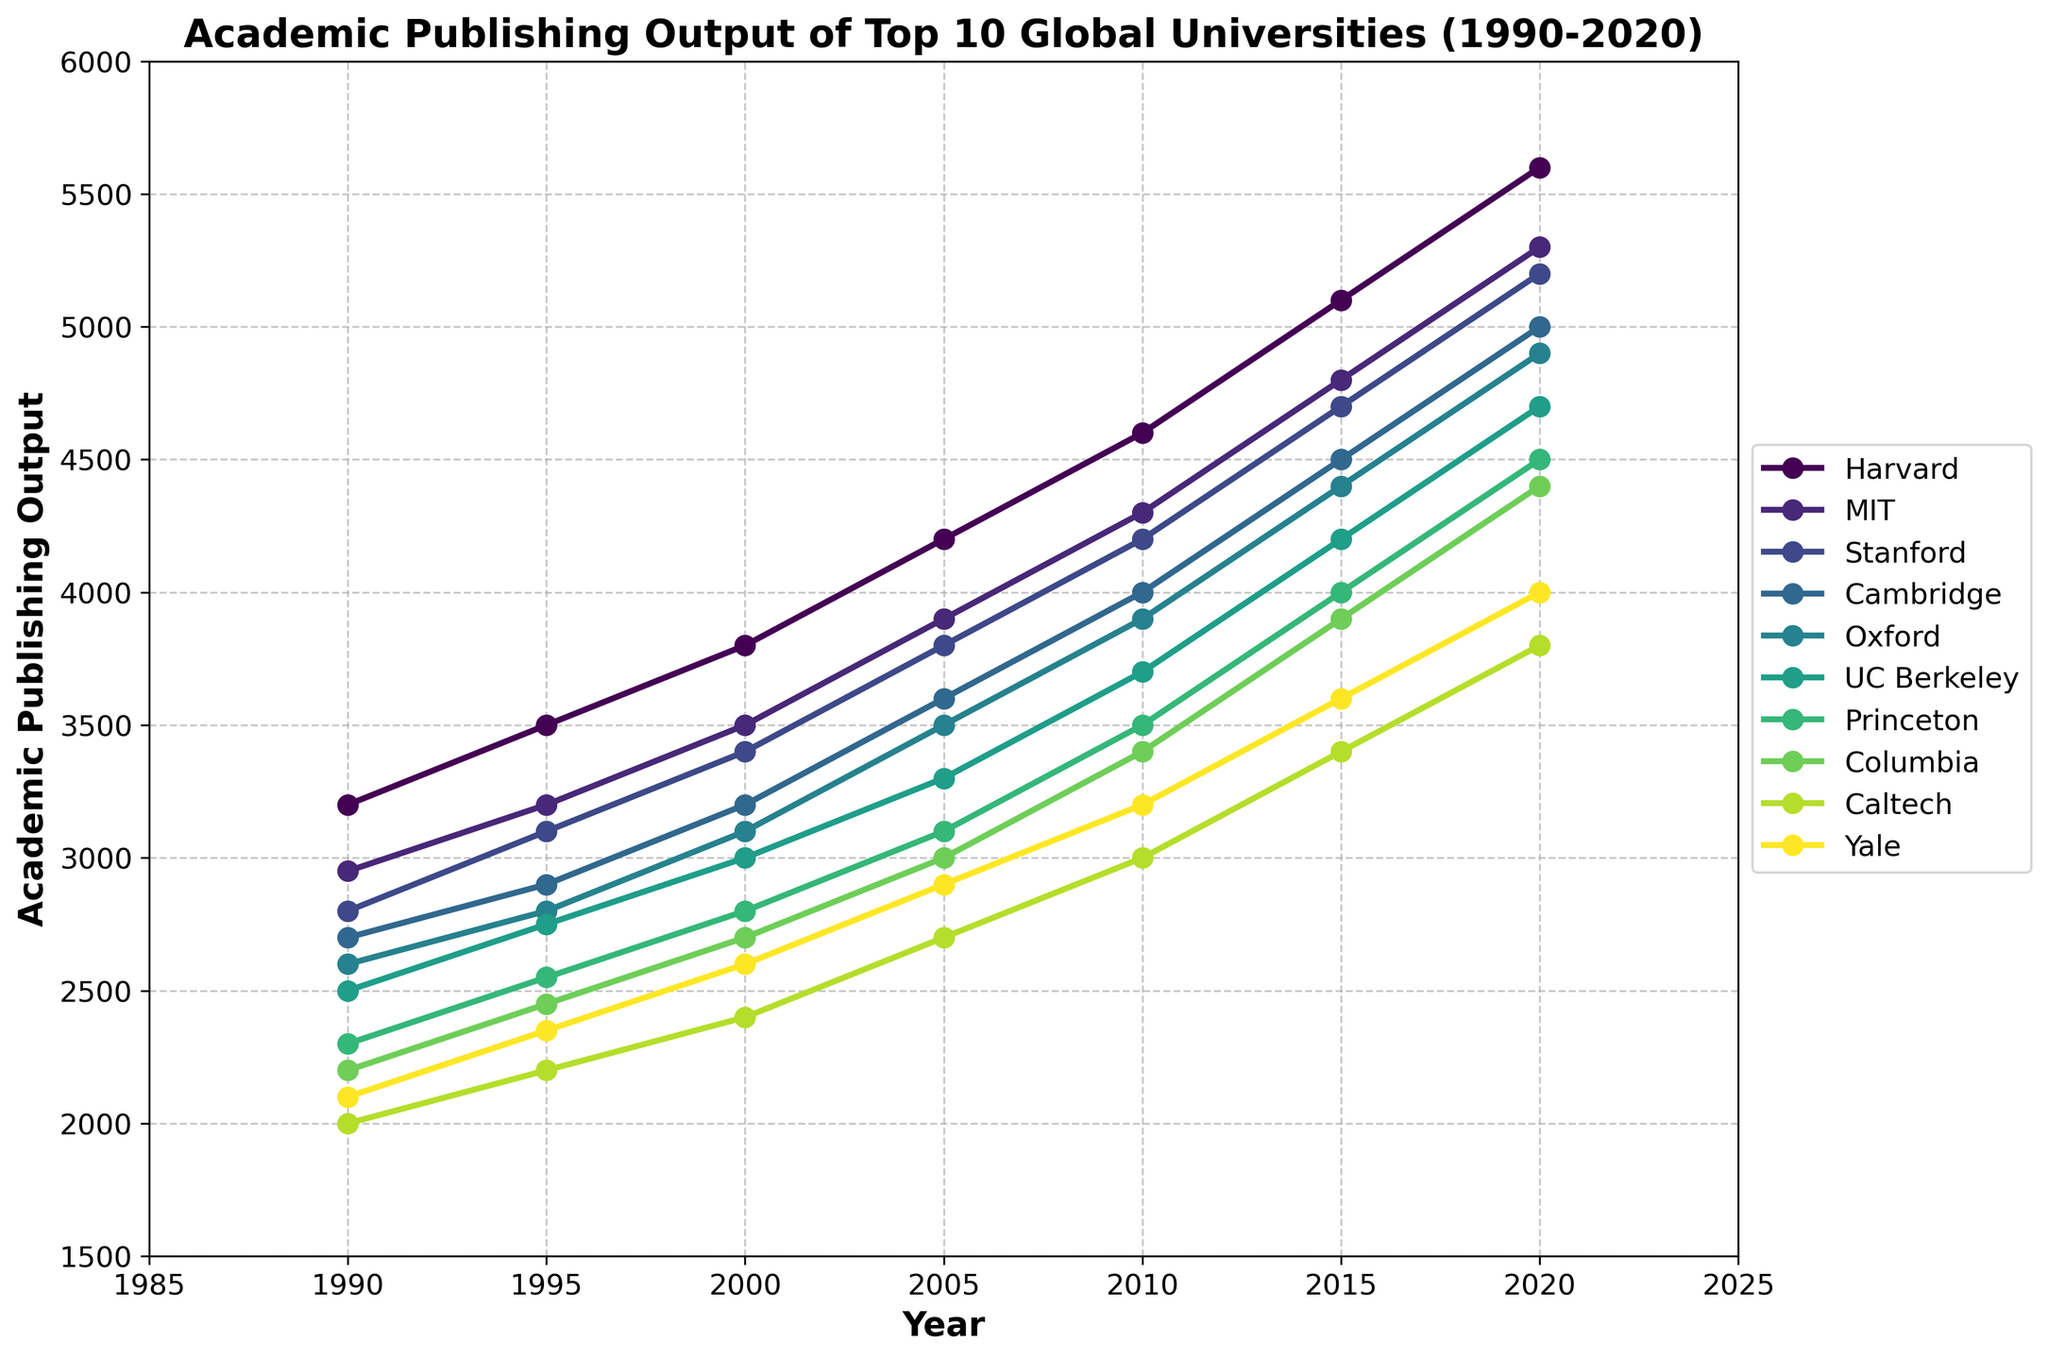What is the publishing output of MIT in 2010? From the figure, look at the point corresponding to MIT for the year 2010. According to the plot, MIT's academic publishing output for that year is 4300.
Answer: 4300 Which university had the highest publishing output in 2020? Look for the highest point on the plot for the year 2020. Harvard has the highest publishing output in 2020 with 5600.
Answer: Harvard How does Harvard's publishing output in 2020 compare to its output in 1990? Identify Harvard's publishing output in both 2020 and 1990. Harvard's output in 2020 is 5600, and in 1990 it is 3200. The difference is 5600 - 3200 = 2400, so it increased by 2400.
Answer: Harvard's publishing output increased by 2400 Between 1990 and 2020, which university showed the greatest increase in academic publishing output? Calculate the increase for each university over the period by subtracting the 1990 output from the 2020 output. Harvard: 5600 - 3200 = 2400, MIT: 5300 - 2950 = 2350, Stanford: 5200 - 2800 = 2400, Cambridge: 5000 - 2700 = 2300, Oxford: 4900 - 2600 = 2300, UC Berkeley: 4700 - 2500 = 2200, Princeton: 4500 - 2300 = 2200, Columbia: 4400 - 2200 = 2200, Caltech: 3800 - 2000 = 1800, Yale: 4000 - 2100 = 1900. The greatest increase is shared between Harvard and Stanford, both with an increase of 2400.
Answer: Harvard and Stanford Compare the publishing outputs of Oxford and Cambridge in 2020 and provide the difference. Find the 2020 values for Oxford and Cambridge. Oxford: 4900, Cambridge: 5000. The difference is 5000 - 4900 = 100.
Answer: 100 What was the average academic publishing output for Yale from 1990 to 2020? Calculate the average output by summing the outputs for all the years and then dividing by the number of years. (2100 + 2350 + 2600 + 2900 + 3200 + 3600 + 4000) / 7 = 36050 / 7 ≈ 5150 / 7 ≈ 3221.43.
Answer: ≈ 3221.43 Which university had the lowest publishing output in 2000? Identify the lowest point on the plot for the year 2000. Caltech has the lowest publishing output in 2000 with 2400.
Answer: Caltech What is the trend of academic publishing output for UC Berkeley between 1990 and 2020? Observe the plot for UC Berkeley from 1990 to 2020. UC Berkeley's publishing output shows a steady upward trend from 2500 in 1990 to 4700 in 2020.
Answer: Upward trend How many universities had a publishing output greater than 4000 in 2015? Look at the plot for the year 2015 and count the universities with outputs greater than 4000. Harvard, MIT, Stanford, Cambridge, Oxford, and UC Berkeley have outputs greater than 4000. There are 6 universities.
Answer: 6 By how much did Princeton's publishing output increase from 1995 to 2015? Calculate the difference between Princeton's publishing output in 2015 and 1995. The output in 2015 is 4000 and in 1995 it is 2550. The increase is 4000 - 2550 = 1450.
Answer: 1450 